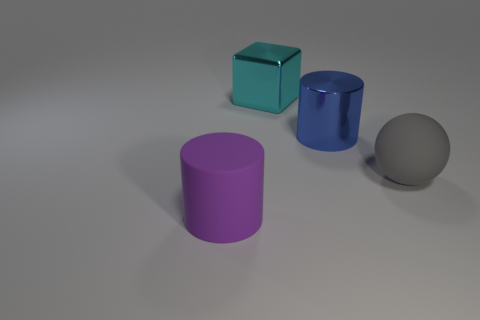Add 4 red metallic blocks. How many objects exist? 8 Subtract all blue cylinders. How many cylinders are left? 1 Subtract 0 red cubes. How many objects are left? 4 Subtract all cubes. How many objects are left? 3 Subtract 2 cylinders. How many cylinders are left? 0 Subtract all green cubes. Subtract all yellow cylinders. How many cubes are left? 1 Subtract all yellow balls. How many blue blocks are left? 0 Subtract all large blue things. Subtract all big purple cylinders. How many objects are left? 2 Add 4 purple cylinders. How many purple cylinders are left? 5 Add 2 cyan blocks. How many cyan blocks exist? 3 